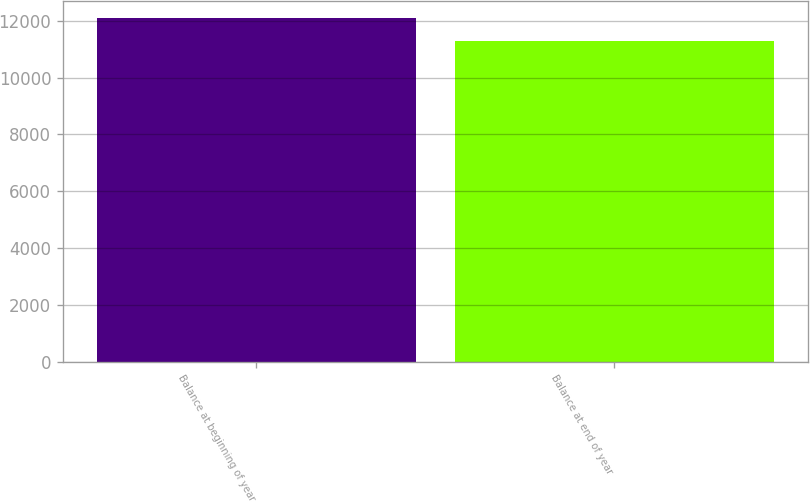Convert chart. <chart><loc_0><loc_0><loc_500><loc_500><bar_chart><fcel>Balance at beginning of year<fcel>Balance at end of year<nl><fcel>12100<fcel>11289<nl></chart> 